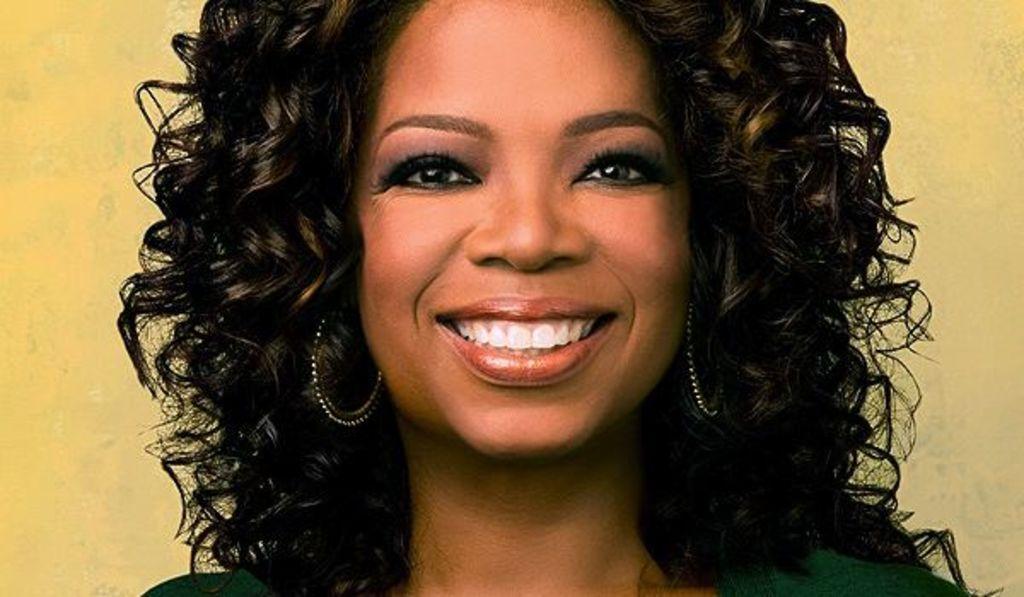Describe this image in one or two sentences. In this image we can see a lady smiling. She is wearing earrings. 